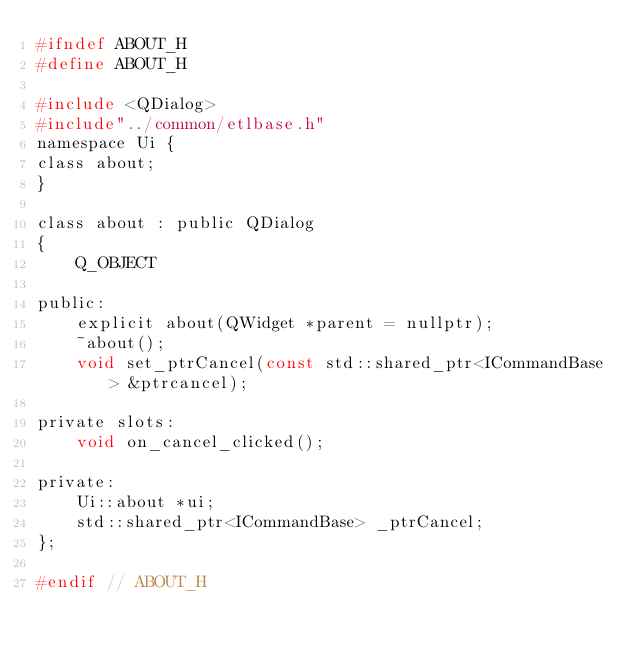<code> <loc_0><loc_0><loc_500><loc_500><_C_>#ifndef ABOUT_H
#define ABOUT_H

#include <QDialog>
#include"../common/etlbase.h"
namespace Ui {
class about;
}

class about : public QDialog
{
    Q_OBJECT

public:
    explicit about(QWidget *parent = nullptr);
    ~about();
    void set_ptrCancel(const std::shared_ptr<ICommandBase> &ptrcancel);

private slots:
    void on_cancel_clicked();

private:
    Ui::about *ui;
    std::shared_ptr<ICommandBase> _ptrCancel;
};

#endif // ABOUT_H
</code> 